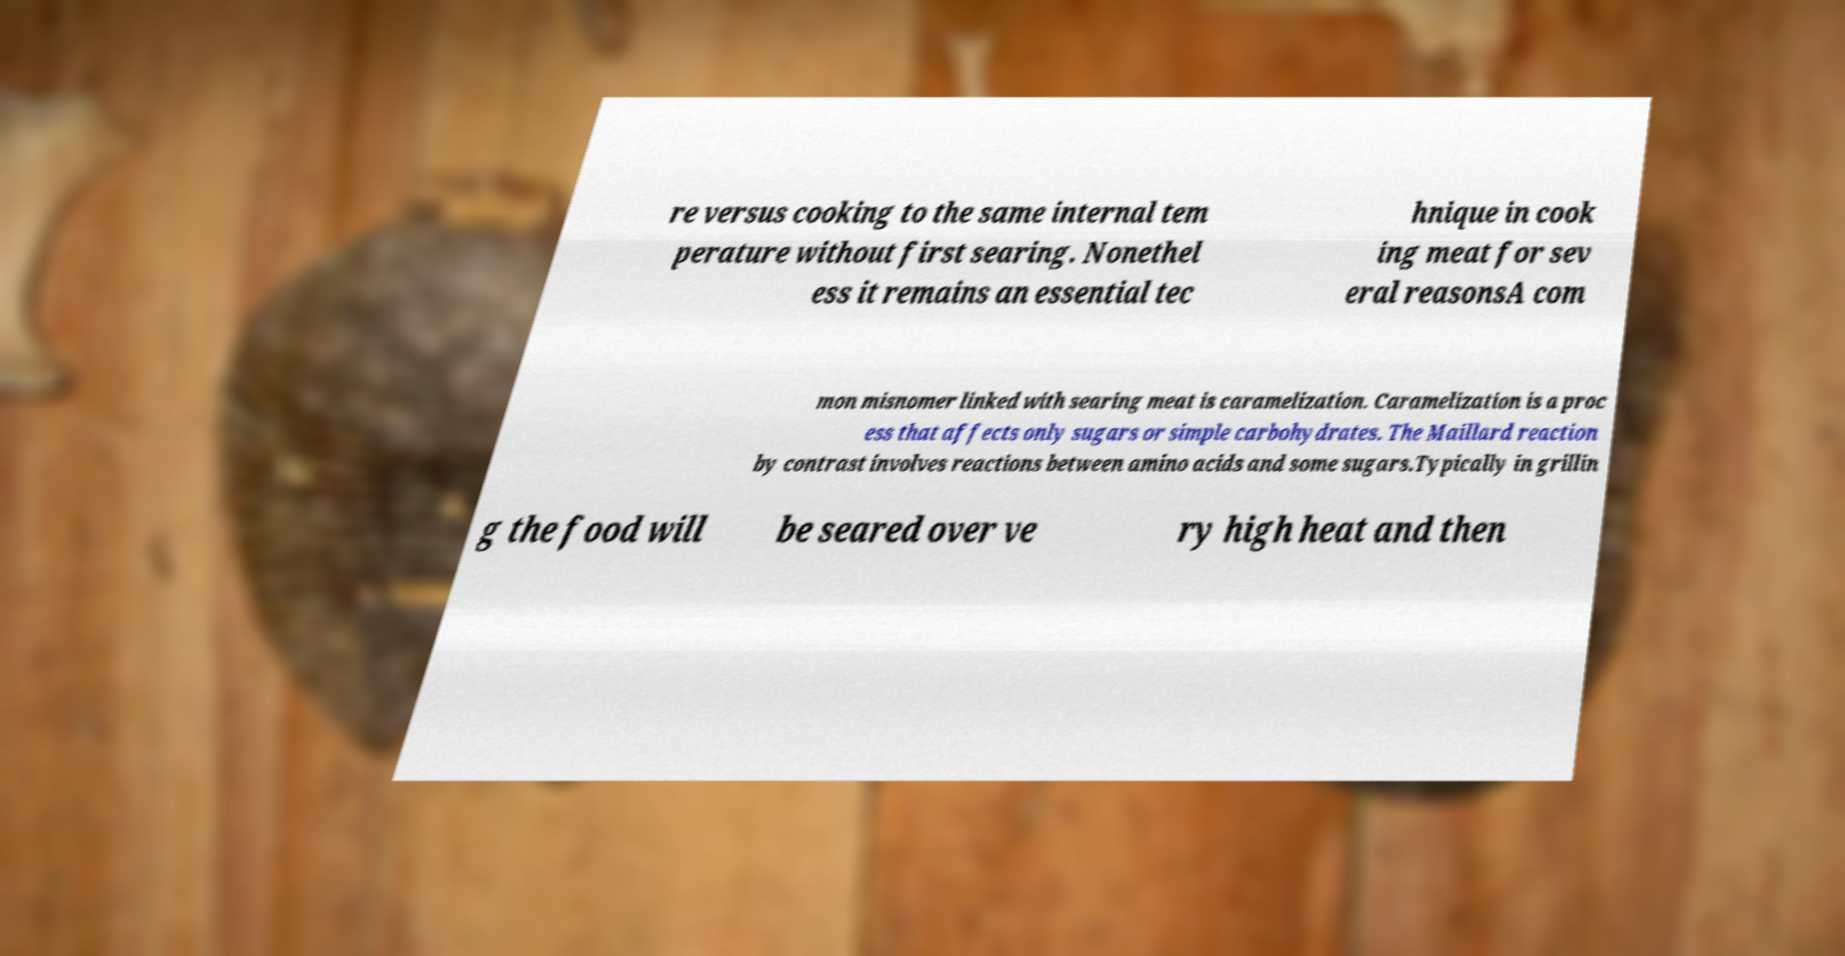Could you assist in decoding the text presented in this image and type it out clearly? re versus cooking to the same internal tem perature without first searing. Nonethel ess it remains an essential tec hnique in cook ing meat for sev eral reasonsA com mon misnomer linked with searing meat is caramelization. Caramelization is a proc ess that affects only sugars or simple carbohydrates. The Maillard reaction by contrast involves reactions between amino acids and some sugars.Typically in grillin g the food will be seared over ve ry high heat and then 